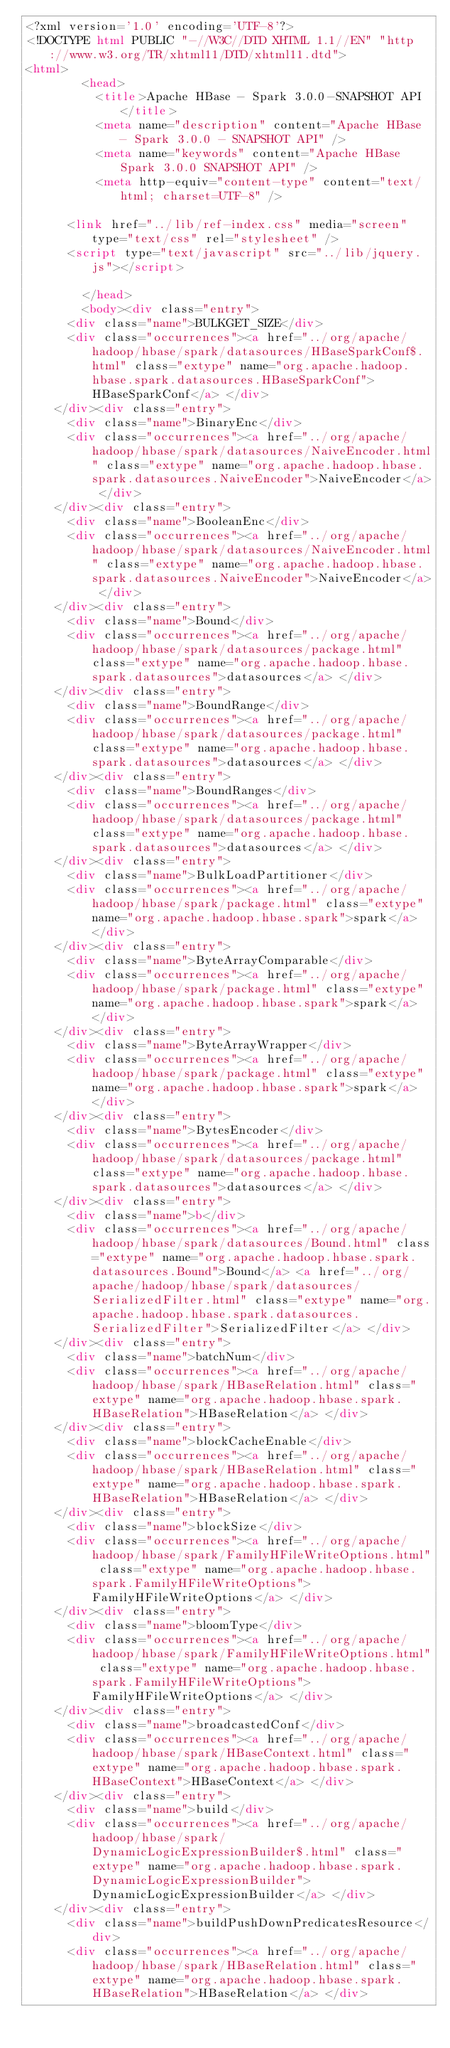Convert code to text. <code><loc_0><loc_0><loc_500><loc_500><_HTML_><?xml version='1.0' encoding='UTF-8'?>
<!DOCTYPE html PUBLIC "-//W3C//DTD XHTML 1.1//EN" "http://www.w3.org/TR/xhtml11/DTD/xhtml11.dtd">
<html>
        <head>
          <title>Apache HBase - Spark 3.0.0-SNAPSHOT API</title>
          <meta name="description" content="Apache HBase - Spark 3.0.0 - SNAPSHOT API" />
          <meta name="keywords" content="Apache HBase Spark 3.0.0 SNAPSHOT API" />
          <meta http-equiv="content-type" content="text/html; charset=UTF-8" />
          
      <link href="../lib/ref-index.css" media="screen" type="text/css" rel="stylesheet" />
      <script type="text/javascript" src="../lib/jquery.js"></script>
    
        </head>
        <body><div class="entry">
      <div class="name">BULKGET_SIZE</div>
      <div class="occurrences"><a href="../org/apache/hadoop/hbase/spark/datasources/HBaseSparkConf$.html" class="extype" name="org.apache.hadoop.hbase.spark.datasources.HBaseSparkConf">HBaseSparkConf</a> </div>
    </div><div class="entry">
      <div class="name">BinaryEnc</div>
      <div class="occurrences"><a href="../org/apache/hadoop/hbase/spark/datasources/NaiveEncoder.html" class="extype" name="org.apache.hadoop.hbase.spark.datasources.NaiveEncoder">NaiveEncoder</a> </div>
    </div><div class="entry">
      <div class="name">BooleanEnc</div>
      <div class="occurrences"><a href="../org/apache/hadoop/hbase/spark/datasources/NaiveEncoder.html" class="extype" name="org.apache.hadoop.hbase.spark.datasources.NaiveEncoder">NaiveEncoder</a> </div>
    </div><div class="entry">
      <div class="name">Bound</div>
      <div class="occurrences"><a href="../org/apache/hadoop/hbase/spark/datasources/package.html" class="extype" name="org.apache.hadoop.hbase.spark.datasources">datasources</a> </div>
    </div><div class="entry">
      <div class="name">BoundRange</div>
      <div class="occurrences"><a href="../org/apache/hadoop/hbase/spark/datasources/package.html" class="extype" name="org.apache.hadoop.hbase.spark.datasources">datasources</a> </div>
    </div><div class="entry">
      <div class="name">BoundRanges</div>
      <div class="occurrences"><a href="../org/apache/hadoop/hbase/spark/datasources/package.html" class="extype" name="org.apache.hadoop.hbase.spark.datasources">datasources</a> </div>
    </div><div class="entry">
      <div class="name">BulkLoadPartitioner</div>
      <div class="occurrences"><a href="../org/apache/hadoop/hbase/spark/package.html" class="extype" name="org.apache.hadoop.hbase.spark">spark</a> </div>
    </div><div class="entry">
      <div class="name">ByteArrayComparable</div>
      <div class="occurrences"><a href="../org/apache/hadoop/hbase/spark/package.html" class="extype" name="org.apache.hadoop.hbase.spark">spark</a> </div>
    </div><div class="entry">
      <div class="name">ByteArrayWrapper</div>
      <div class="occurrences"><a href="../org/apache/hadoop/hbase/spark/package.html" class="extype" name="org.apache.hadoop.hbase.spark">spark</a> </div>
    </div><div class="entry">
      <div class="name">BytesEncoder</div>
      <div class="occurrences"><a href="../org/apache/hadoop/hbase/spark/datasources/package.html" class="extype" name="org.apache.hadoop.hbase.spark.datasources">datasources</a> </div>
    </div><div class="entry">
      <div class="name">b</div>
      <div class="occurrences"><a href="../org/apache/hadoop/hbase/spark/datasources/Bound.html" class="extype" name="org.apache.hadoop.hbase.spark.datasources.Bound">Bound</a> <a href="../org/apache/hadoop/hbase/spark/datasources/SerializedFilter.html" class="extype" name="org.apache.hadoop.hbase.spark.datasources.SerializedFilter">SerializedFilter</a> </div>
    </div><div class="entry">
      <div class="name">batchNum</div>
      <div class="occurrences"><a href="../org/apache/hadoop/hbase/spark/HBaseRelation.html" class="extype" name="org.apache.hadoop.hbase.spark.HBaseRelation">HBaseRelation</a> </div>
    </div><div class="entry">
      <div class="name">blockCacheEnable</div>
      <div class="occurrences"><a href="../org/apache/hadoop/hbase/spark/HBaseRelation.html" class="extype" name="org.apache.hadoop.hbase.spark.HBaseRelation">HBaseRelation</a> </div>
    </div><div class="entry">
      <div class="name">blockSize</div>
      <div class="occurrences"><a href="../org/apache/hadoop/hbase/spark/FamilyHFileWriteOptions.html" class="extype" name="org.apache.hadoop.hbase.spark.FamilyHFileWriteOptions">FamilyHFileWriteOptions</a> </div>
    </div><div class="entry">
      <div class="name">bloomType</div>
      <div class="occurrences"><a href="../org/apache/hadoop/hbase/spark/FamilyHFileWriteOptions.html" class="extype" name="org.apache.hadoop.hbase.spark.FamilyHFileWriteOptions">FamilyHFileWriteOptions</a> </div>
    </div><div class="entry">
      <div class="name">broadcastedConf</div>
      <div class="occurrences"><a href="../org/apache/hadoop/hbase/spark/HBaseContext.html" class="extype" name="org.apache.hadoop.hbase.spark.HBaseContext">HBaseContext</a> </div>
    </div><div class="entry">
      <div class="name">build</div>
      <div class="occurrences"><a href="../org/apache/hadoop/hbase/spark/DynamicLogicExpressionBuilder$.html" class="extype" name="org.apache.hadoop.hbase.spark.DynamicLogicExpressionBuilder">DynamicLogicExpressionBuilder</a> </div>
    </div><div class="entry">
      <div class="name">buildPushDownPredicatesResource</div>
      <div class="occurrences"><a href="../org/apache/hadoop/hbase/spark/HBaseRelation.html" class="extype" name="org.apache.hadoop.hbase.spark.HBaseRelation">HBaseRelation</a> </div></code> 